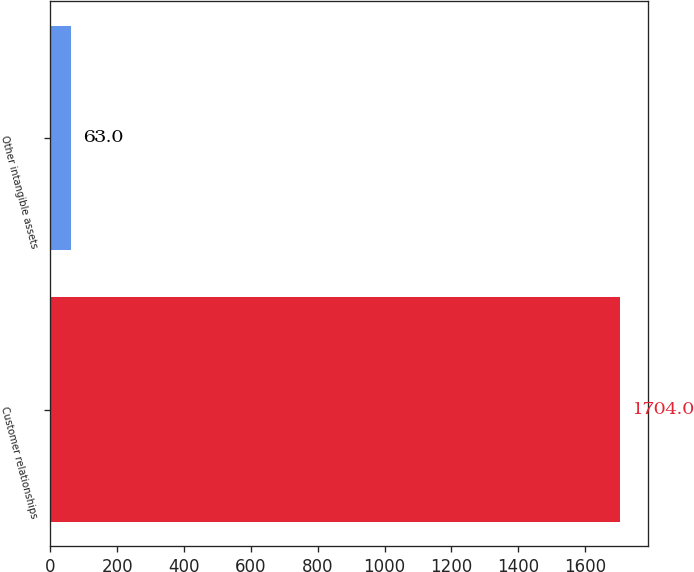<chart> <loc_0><loc_0><loc_500><loc_500><bar_chart><fcel>Customer relationships<fcel>Other intangible assets<nl><fcel>1704<fcel>63<nl></chart> 